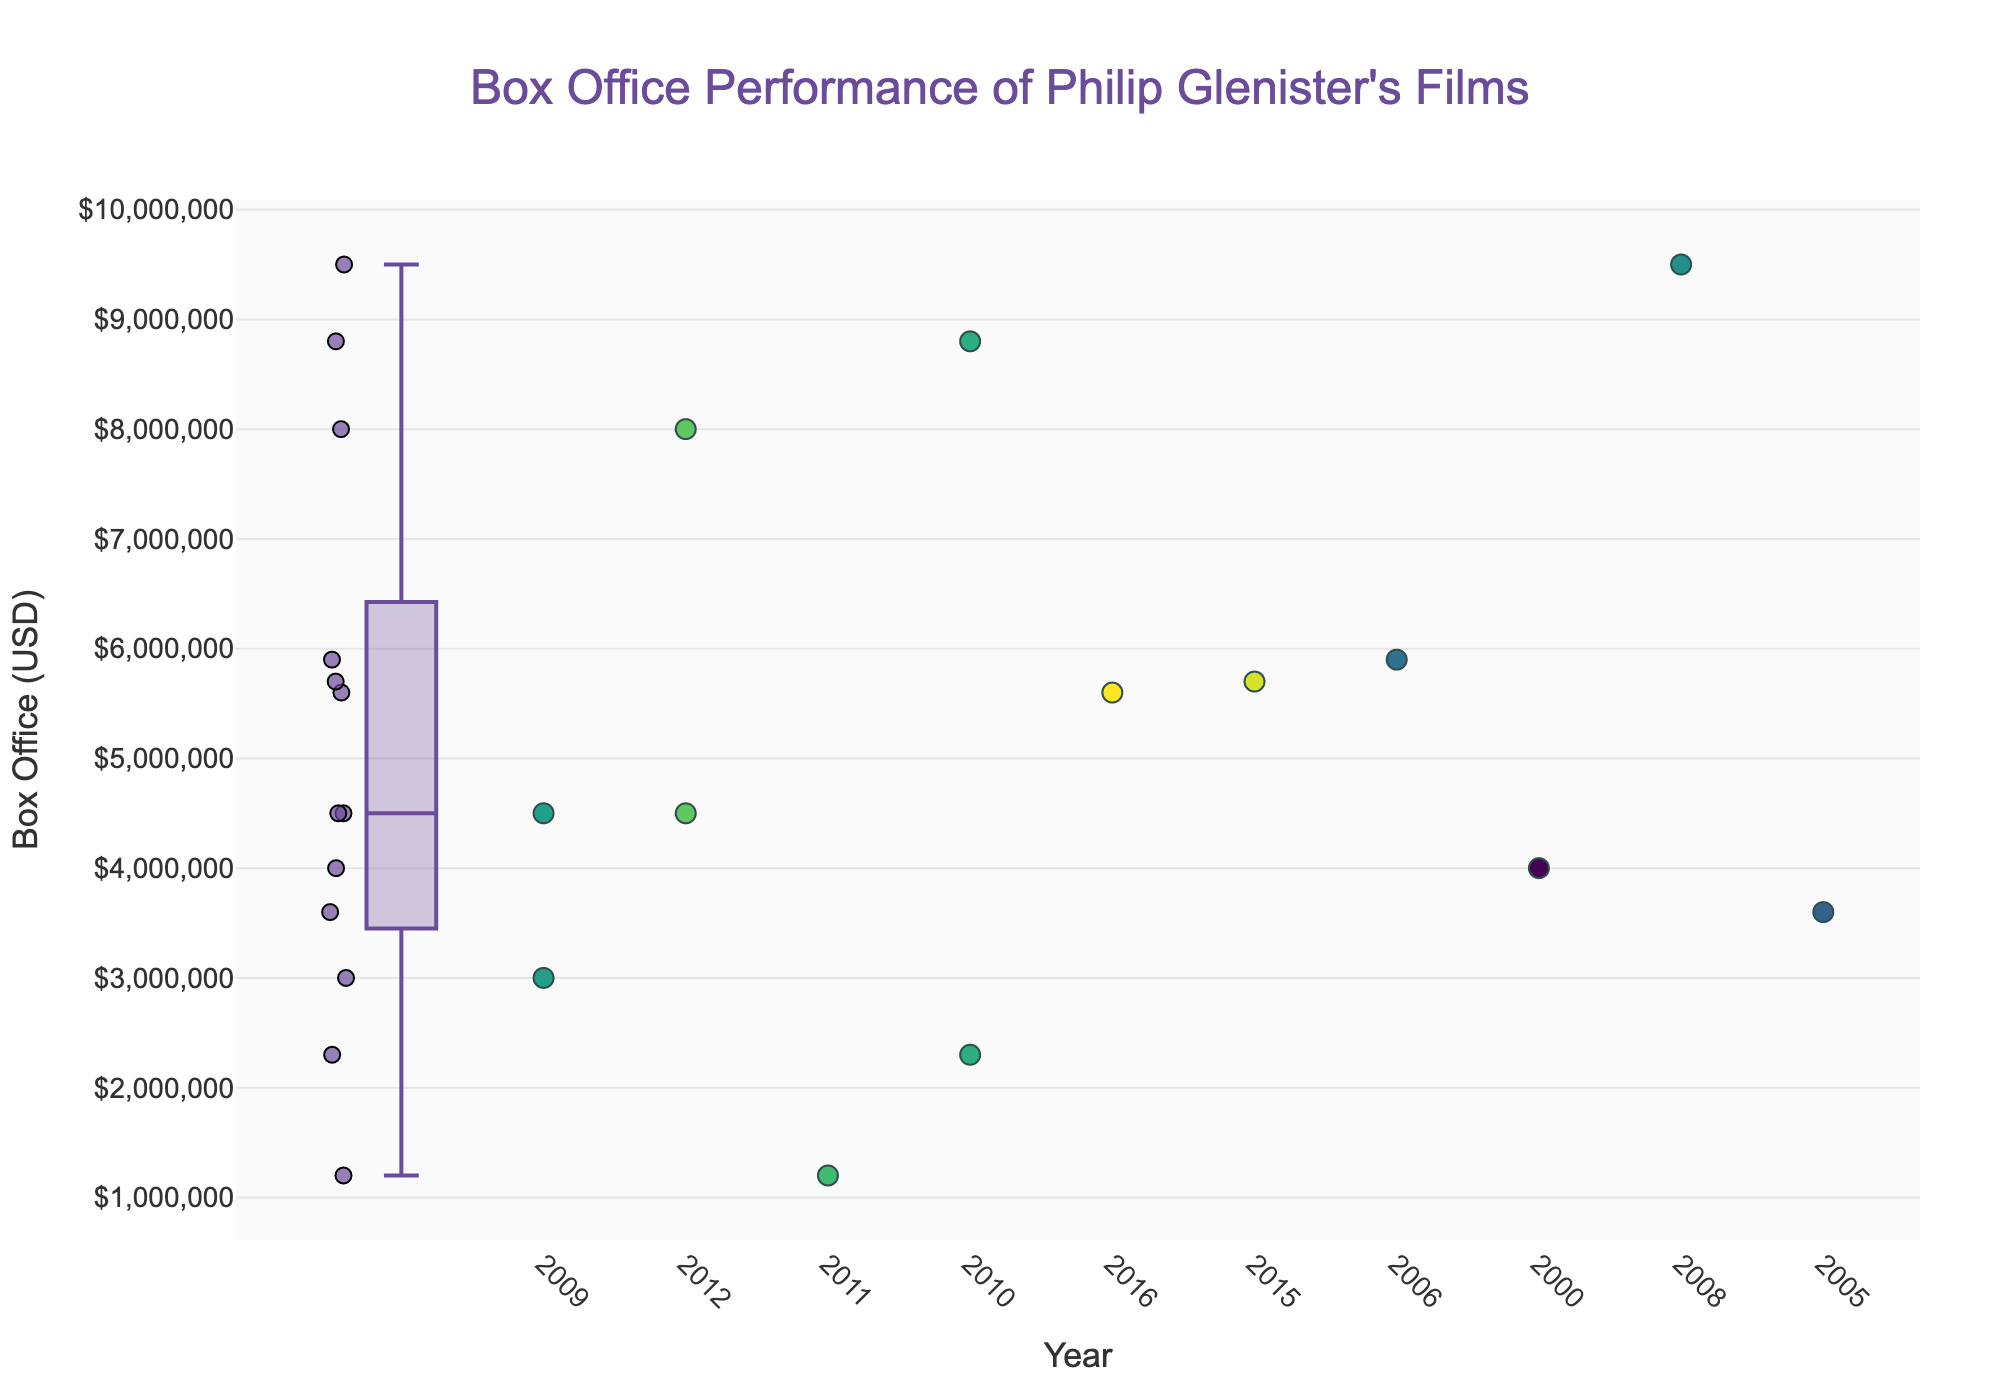Which film has the highest box office performance? Identify the highest point on the box plot and hover over the scatter points to see the film name. The highest box office performance is "Ashes to Ashes".
Answer: Ashes to Ashes What is the title of the plot? The plot title is clearly shown at the top of the figure: "Box Office Performance of Philip Glenister's Films".
Answer: Box Office Performance of Philip Glenister's Films How many films are represented in the scatter plot? Count the individual scatter points on the plot. There are thirteen films in total.
Answer: 13 Which year had three films released? Hover over the scatter points to identify the years. The year 2009 had three films: "The Unloved", "The Other Side of Love", and "Ashes to Ashes".
Answer: 2009 What is the median box office performance of Philip Glenister's films? Look at the box plot and identify the median line within the box. The median value appears to be around $4,500,000.
Answer: $4,500,000 How does the box office performance of "Life on Mars" compare to "Roger & Val Have Just Got In"? Hover over the scatter points to identify the performance of both films. "Life on Mars" has a box office of $5,900,000 while "Roger & Val Have Just Got In" has $2,300,000. So, "Life on Mars" performed better.
Answer: Life on Mars performed better What is the range of the box office performances? Identify the upper and lower extremes (whiskers) of the box plot. The minimum is around $1,200,000 (Kingdom of Dust) and the maximum is around $9,500,000 (Ashes to Ashes). The range is $9,500,000 - $1,200,000 = $8,300,000.
Answer: $8,300,000 Which film released in 2012 had a higher box office performance? Hover over the scatter points for the year 2012. "Bel Ami" had $8,000,000, and "Inside Men" had $4,500,000. "Bel Ami" had higher performance.
Answer: Bel Ami Are there any years with only one film release? If so, which year and film? Hover over scatter points for each year to check for the number of films. The year 2000 had only one film: "Clocking Off".
Answer: 2000, Clocking Off 